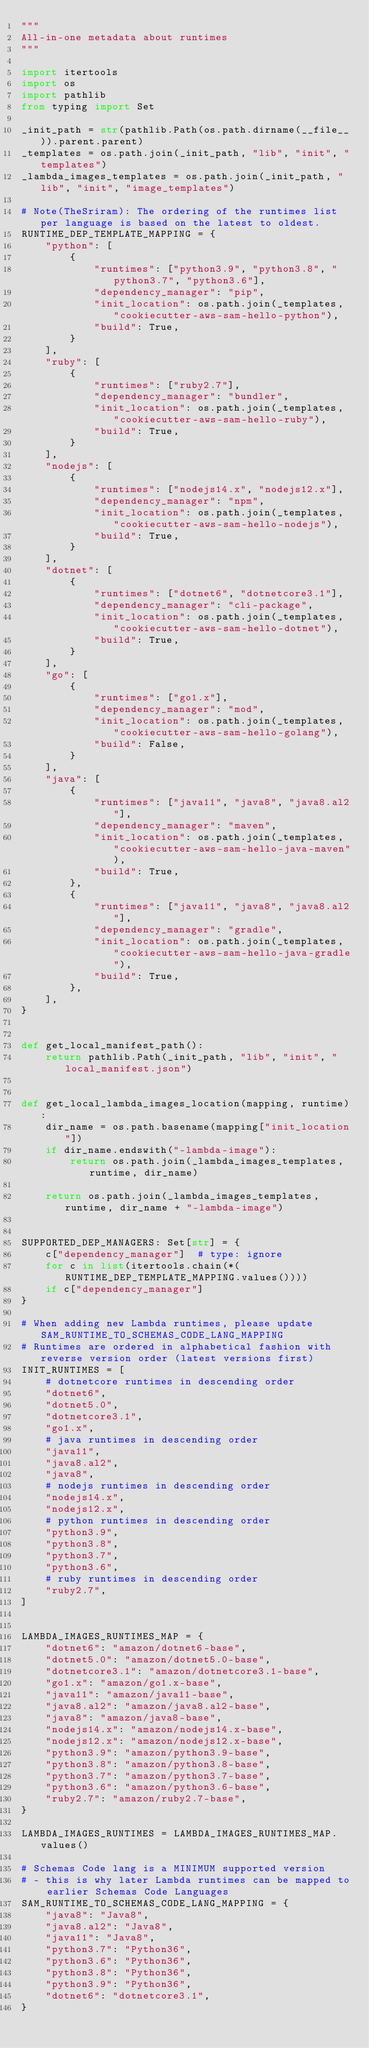<code> <loc_0><loc_0><loc_500><loc_500><_Python_>"""
All-in-one metadata about runtimes
"""

import itertools
import os
import pathlib
from typing import Set

_init_path = str(pathlib.Path(os.path.dirname(__file__)).parent.parent)
_templates = os.path.join(_init_path, "lib", "init", "templates")
_lambda_images_templates = os.path.join(_init_path, "lib", "init", "image_templates")

# Note(TheSriram): The ordering of the runtimes list per language is based on the latest to oldest.
RUNTIME_DEP_TEMPLATE_MAPPING = {
    "python": [
        {
            "runtimes": ["python3.9", "python3.8", "python3.7", "python3.6"],
            "dependency_manager": "pip",
            "init_location": os.path.join(_templates, "cookiecutter-aws-sam-hello-python"),
            "build": True,
        }
    ],
    "ruby": [
        {
            "runtimes": ["ruby2.7"],
            "dependency_manager": "bundler",
            "init_location": os.path.join(_templates, "cookiecutter-aws-sam-hello-ruby"),
            "build": True,
        }
    ],
    "nodejs": [
        {
            "runtimes": ["nodejs14.x", "nodejs12.x"],
            "dependency_manager": "npm",
            "init_location": os.path.join(_templates, "cookiecutter-aws-sam-hello-nodejs"),
            "build": True,
        }
    ],
    "dotnet": [
        {
            "runtimes": ["dotnet6", "dotnetcore3.1"],
            "dependency_manager": "cli-package",
            "init_location": os.path.join(_templates, "cookiecutter-aws-sam-hello-dotnet"),
            "build": True,
        }
    ],
    "go": [
        {
            "runtimes": ["go1.x"],
            "dependency_manager": "mod",
            "init_location": os.path.join(_templates, "cookiecutter-aws-sam-hello-golang"),
            "build": False,
        }
    ],
    "java": [
        {
            "runtimes": ["java11", "java8", "java8.al2"],
            "dependency_manager": "maven",
            "init_location": os.path.join(_templates, "cookiecutter-aws-sam-hello-java-maven"),
            "build": True,
        },
        {
            "runtimes": ["java11", "java8", "java8.al2"],
            "dependency_manager": "gradle",
            "init_location": os.path.join(_templates, "cookiecutter-aws-sam-hello-java-gradle"),
            "build": True,
        },
    ],
}


def get_local_manifest_path():
    return pathlib.Path(_init_path, "lib", "init", "local_manifest.json")


def get_local_lambda_images_location(mapping, runtime):
    dir_name = os.path.basename(mapping["init_location"])
    if dir_name.endswith("-lambda-image"):
        return os.path.join(_lambda_images_templates, runtime, dir_name)

    return os.path.join(_lambda_images_templates, runtime, dir_name + "-lambda-image")


SUPPORTED_DEP_MANAGERS: Set[str] = {
    c["dependency_manager"]  # type: ignore
    for c in list(itertools.chain(*(RUNTIME_DEP_TEMPLATE_MAPPING.values())))
    if c["dependency_manager"]
}

# When adding new Lambda runtimes, please update SAM_RUNTIME_TO_SCHEMAS_CODE_LANG_MAPPING
# Runtimes are ordered in alphabetical fashion with reverse version order (latest versions first)
INIT_RUNTIMES = [
    # dotnetcore runtimes in descending order
    "dotnet6",
    "dotnet5.0",
    "dotnetcore3.1",
    "go1.x",
    # java runtimes in descending order
    "java11",
    "java8.al2",
    "java8",
    # nodejs runtimes in descending order
    "nodejs14.x",
    "nodejs12.x",
    # python runtimes in descending order
    "python3.9",
    "python3.8",
    "python3.7",
    "python3.6",
    # ruby runtimes in descending order
    "ruby2.7",
]


LAMBDA_IMAGES_RUNTIMES_MAP = {
    "dotnet6": "amazon/dotnet6-base",
    "dotnet5.0": "amazon/dotnet5.0-base",
    "dotnetcore3.1": "amazon/dotnetcore3.1-base",
    "go1.x": "amazon/go1.x-base",
    "java11": "amazon/java11-base",
    "java8.al2": "amazon/java8.al2-base",
    "java8": "amazon/java8-base",
    "nodejs14.x": "amazon/nodejs14.x-base",
    "nodejs12.x": "amazon/nodejs12.x-base",
    "python3.9": "amazon/python3.9-base",
    "python3.8": "amazon/python3.8-base",
    "python3.7": "amazon/python3.7-base",
    "python3.6": "amazon/python3.6-base",
    "ruby2.7": "amazon/ruby2.7-base",
}

LAMBDA_IMAGES_RUNTIMES = LAMBDA_IMAGES_RUNTIMES_MAP.values()

# Schemas Code lang is a MINIMUM supported version
# - this is why later Lambda runtimes can be mapped to earlier Schemas Code Languages
SAM_RUNTIME_TO_SCHEMAS_CODE_LANG_MAPPING = {
    "java8": "Java8",
    "java8.al2": "Java8",
    "java11": "Java8",
    "python3.7": "Python36",
    "python3.6": "Python36",
    "python3.8": "Python36",
    "python3.9": "Python36",
    "dotnet6": "dotnetcore3.1",
}
</code> 